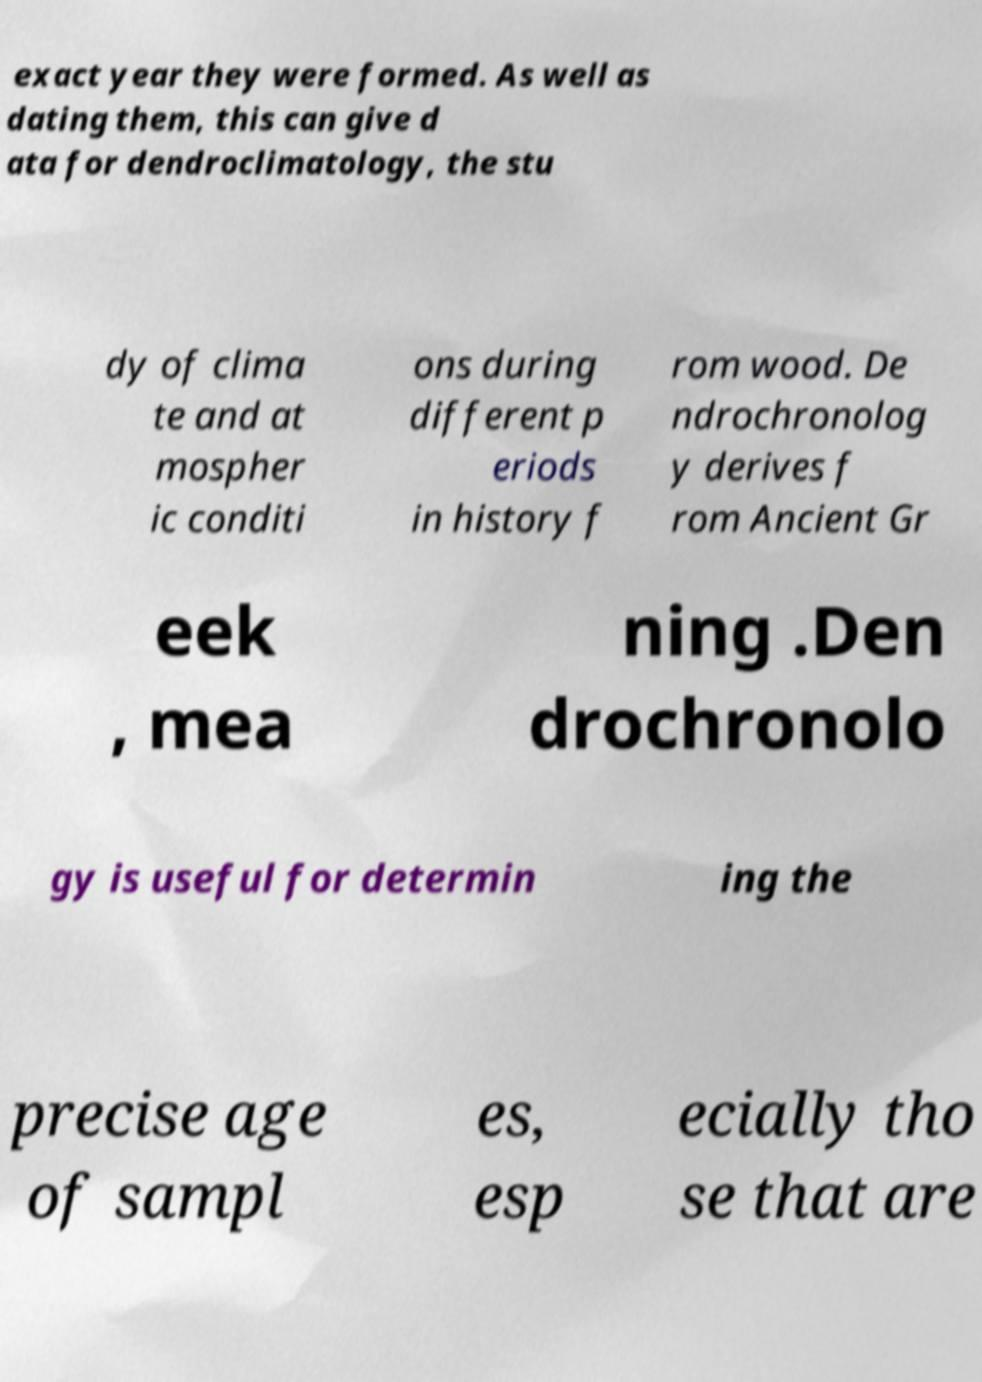Can you read and provide the text displayed in the image?This photo seems to have some interesting text. Can you extract and type it out for me? exact year they were formed. As well as dating them, this can give d ata for dendroclimatology, the stu dy of clima te and at mospher ic conditi ons during different p eriods in history f rom wood. De ndrochronolog y derives f rom Ancient Gr eek , mea ning .Den drochronolo gy is useful for determin ing the precise age of sampl es, esp ecially tho se that are 